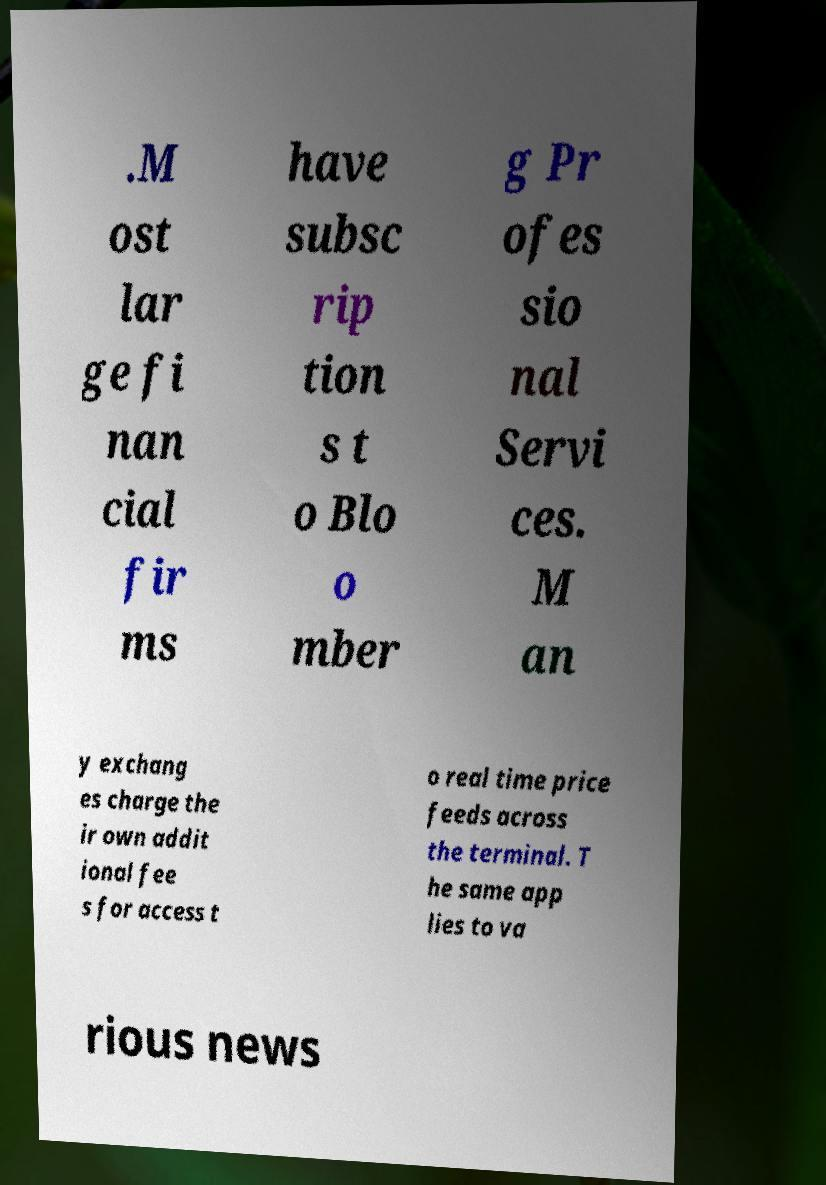What messages or text are displayed in this image? I need them in a readable, typed format. .M ost lar ge fi nan cial fir ms have subsc rip tion s t o Blo o mber g Pr ofes sio nal Servi ces. M an y exchang es charge the ir own addit ional fee s for access t o real time price feeds across the terminal. T he same app lies to va rious news 